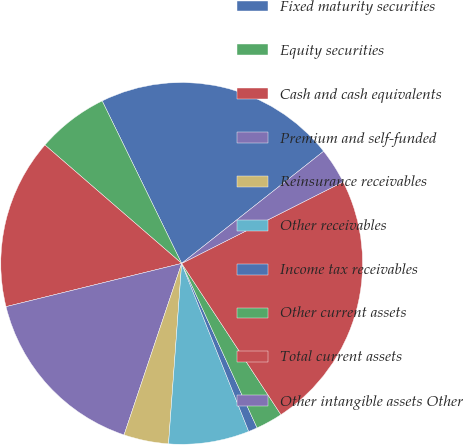<chart> <loc_0><loc_0><loc_500><loc_500><pie_chart><fcel>Fixed maturity securities<fcel>Equity securities<fcel>Cash and cash equivalents<fcel>Premium and self-funded<fcel>Reinsurance receivables<fcel>Other receivables<fcel>Income tax receivables<fcel>Other current assets<fcel>Total current assets<fcel>Other intangible assets Other<nl><fcel>21.6%<fcel>6.4%<fcel>15.2%<fcel>16.0%<fcel>4.0%<fcel>7.2%<fcel>0.8%<fcel>2.4%<fcel>23.2%<fcel>3.2%<nl></chart> 